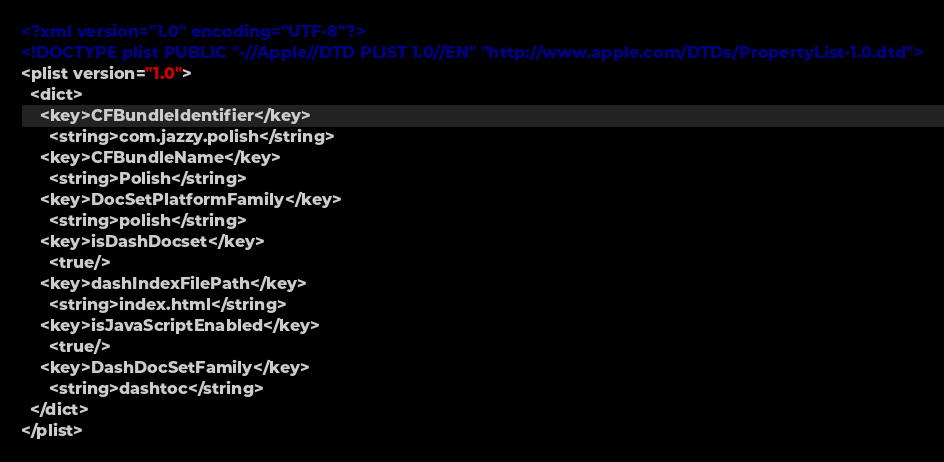Convert code to text. <code><loc_0><loc_0><loc_500><loc_500><_XML_><?xml version="1.0" encoding="UTF-8"?>
<!DOCTYPE plist PUBLIC "-//Apple//DTD PLIST 1.0//EN" "http://www.apple.com/DTDs/PropertyList-1.0.dtd">
<plist version="1.0">
  <dict>
    <key>CFBundleIdentifier</key>
      <string>com.jazzy.polish</string>
    <key>CFBundleName</key>
      <string>Polish</string>
    <key>DocSetPlatformFamily</key>
      <string>polish</string>
    <key>isDashDocset</key>
      <true/>
    <key>dashIndexFilePath</key>
      <string>index.html</string>
    <key>isJavaScriptEnabled</key>
      <true/>
    <key>DashDocSetFamily</key>
      <string>dashtoc</string>
  </dict>
</plist>
</code> 